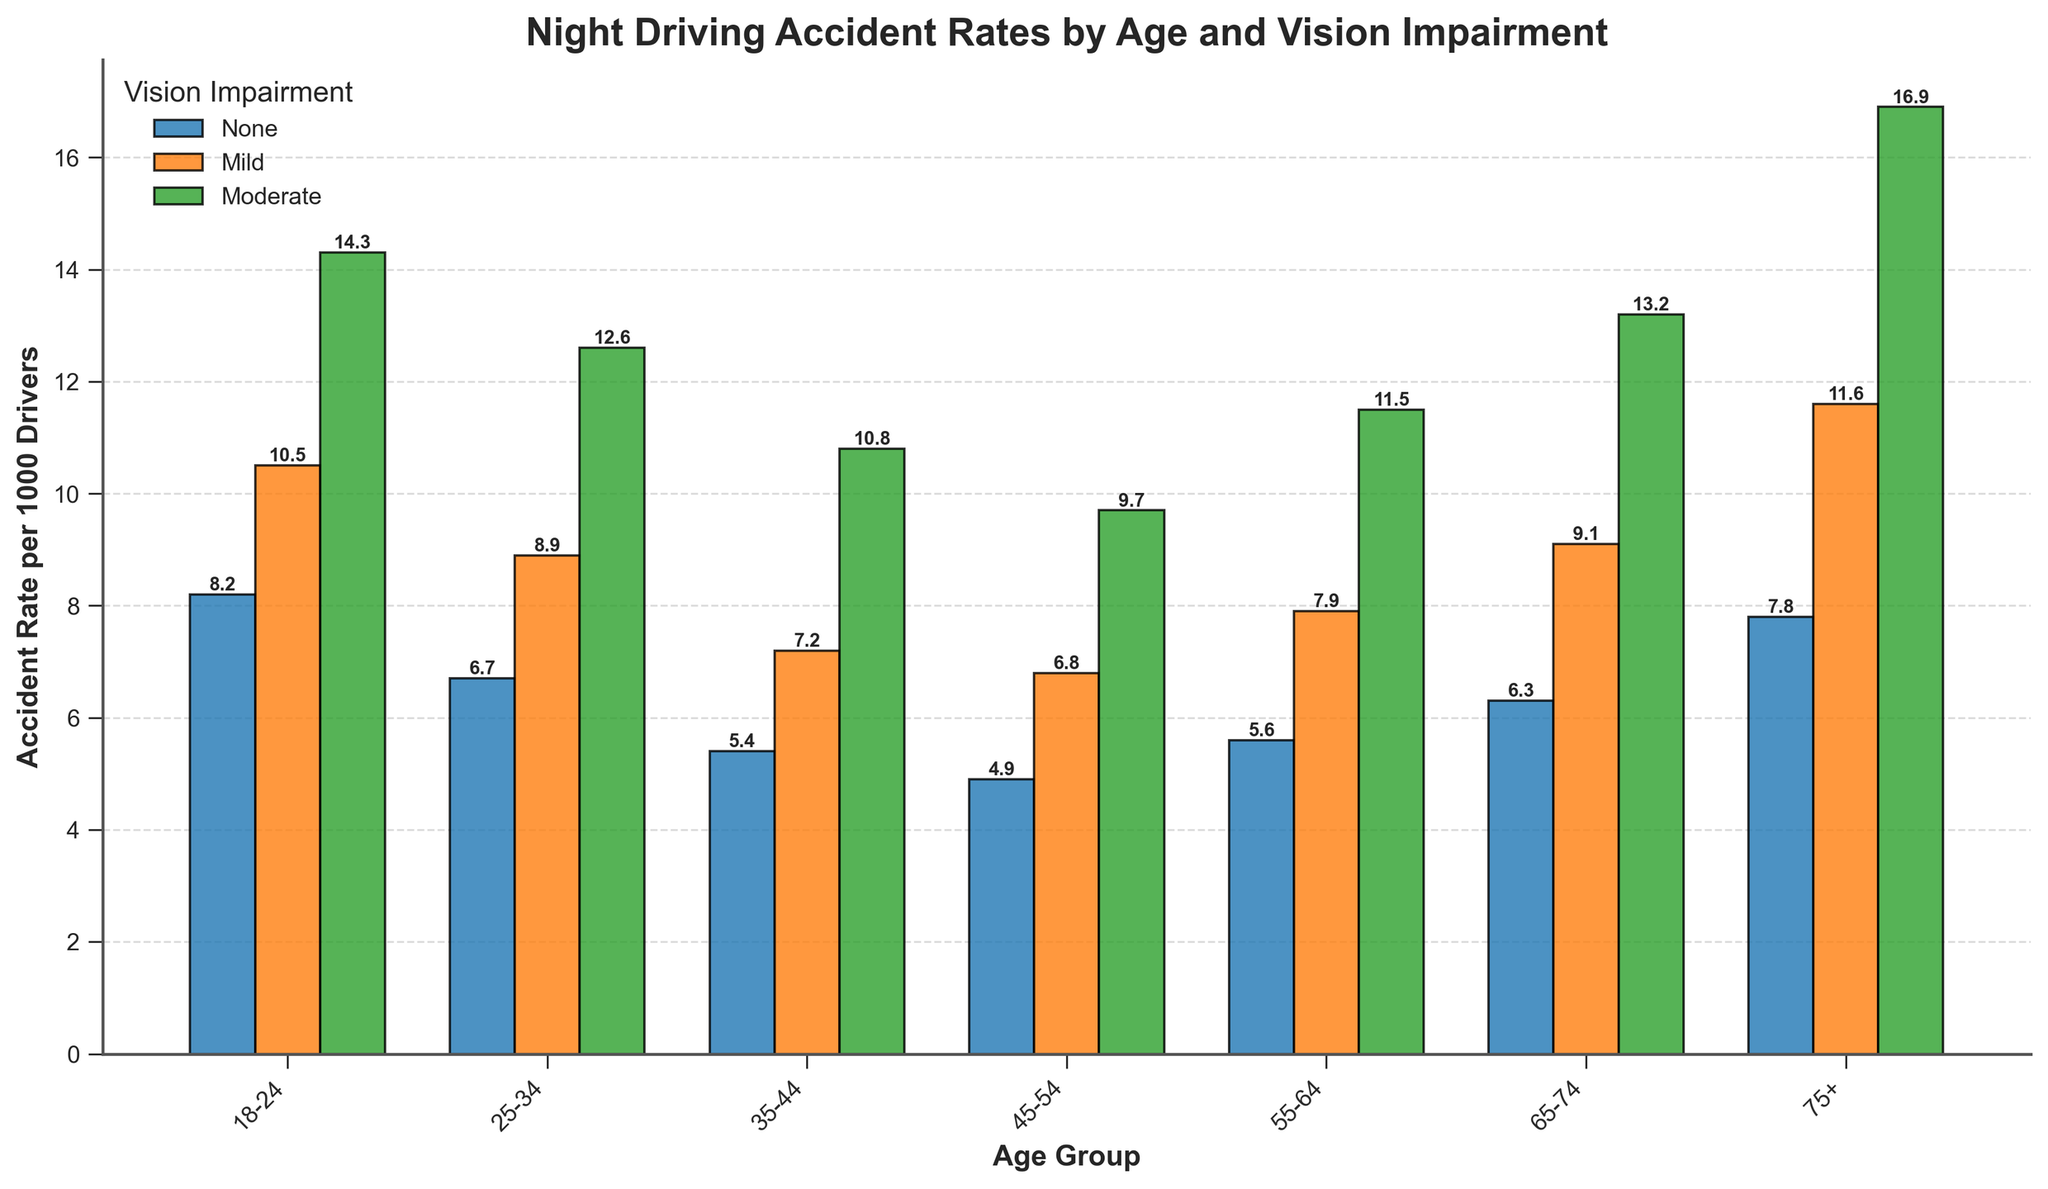How does the accident rate change with age for drivers with no vision impairment? To answer this, look at the bars representing "None" vision impairment across different age groups. Starting from "18-24" to "75+", the accident rates are: 8.2, 6.7, 5.4, 4.9, 5.6, 6.3, and 7.8. This shows a decrease initially and then an increase again.
Answer: Decreases initially, then increases Which age group with moderate vision impairment has the highest night driving accident rate? Check the bars representing "Moderate" vision impairment across different age groups. The highest accident rate is found in the "75+" age group with a value of 16.9.
Answer: 75+ Compare the accident rates for the 55-64 and 65-74 age groups with mild vision impairment. Which group has a higher accident rate? Evaluate the bars corresponding to "55-64" and "65-74" age groups under "Mild" vision impairment. The respective accident rates are 7.9 and 9.1.
Answer: 65-74 What is the difference in accident rates between drivers aged 25-34 with moderate vision impairment and those aged 35-44 with mild vision impairment? Check the accident rates: "25-34 Moderate" is 12.6 and "35-44 Mild" is 7.2. Calculate the difference: 12.6 - 7.2 = 5.4.
Answer: 5.4 What is the average accident rate for the age group 18-24 across all levels of vision impairment? Accumulate the accident rates for the 18-24 age group which are 8.2, 10.5, and 14.3. Sum them up: 8.2 + 10.5 + 14.3 = 33. Divide by 3 (number of data points): 33 / 3 = 11.
Answer: 11 Which vision impairment level has the lowest accident rate for the 45-54 age group? Inspect the bars under the 45-54 age group for "None", "Mild", and "Moderate". The accident rates are 4.9, 6.8, and 9.7 respectively.
Answer: None How much higher is the accident rate for drivers aged 75+ with moderate vision impairment compared to those with no impairment in the same age group? Compare "75+ Moderate" with 16.9 to "75+ None" with 7.8. Subtract: 16.9 - 7.8 = 9.1.
Answer: 9.1 Which age group shows the biggest increase in accident rate from none to mild vision impairment? Calculate the difference between "None" and "Mild" for each age group: 18-24: 10.5 - 8.2 = 2.3, 25-34: 8.9 - 6.7 = 2.2, 35-44: 7.2 - 5.4 = 1.8, 45-54: 6.8 - 4.9 = 1.9, 55-64: 7.9 - 5.6 = 2.3, 65-74: 9.1 - 6.3 = 2.8, 75+: 11.6 - 7.8 = 3.8. The biggest increase is 3.8 for 75+.
Answer: 75+ Among drivers aged 18-24 and 25-34, who has a higher accident rate on average with moderate vision impairment? Compare "18-24 Moderate": 14.3 with "25-34 Moderate": 12.6.
Answer: 18-24 